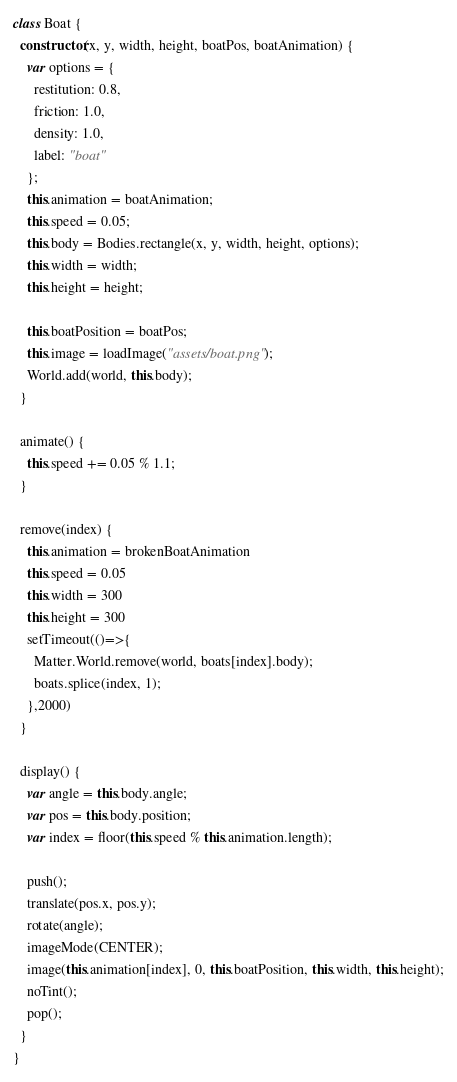<code> <loc_0><loc_0><loc_500><loc_500><_JavaScript_>class Boat {
  constructor(x, y, width, height, boatPos, boatAnimation) {
    var options = {
      restitution: 0.8,
      friction: 1.0,
      density: 1.0,
      label: "boat"
    };
    this.animation = boatAnimation;
    this.speed = 0.05;
    this.body = Bodies.rectangle(x, y, width, height, options);
    this.width = width;
    this.height = height;

    this.boatPosition = boatPos;
    this.image = loadImage("assets/boat.png");
    World.add(world, this.body);
  }

  animate() {
    this.speed += 0.05 % 1.1;
  }

  remove(index) {
    this.animation = brokenBoatAnimation
    this.speed = 0.05
    this.width = 300
    this.height = 300
    setTimeout(()=>{
      Matter.World.remove(world, boats[index].body);
      boats.splice(index, 1);
    },2000)
  }

  display() {
    var angle = this.body.angle;
    var pos = this.body.position;
    var index = floor(this.speed % this.animation.length);
    
    push();
    translate(pos.x, pos.y);
    rotate(angle);
    imageMode(CENTER);
    image(this.animation[index], 0, this.boatPosition, this.width, this.height);
    noTint();
    pop();
  }
}
</code> 